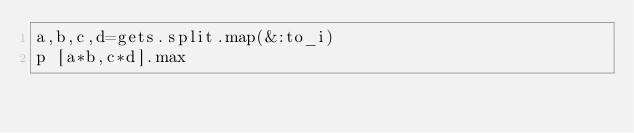Convert code to text. <code><loc_0><loc_0><loc_500><loc_500><_Ruby_>a,b,c,d=gets.split.map(&:to_i)
p [a*b,c*d].max</code> 